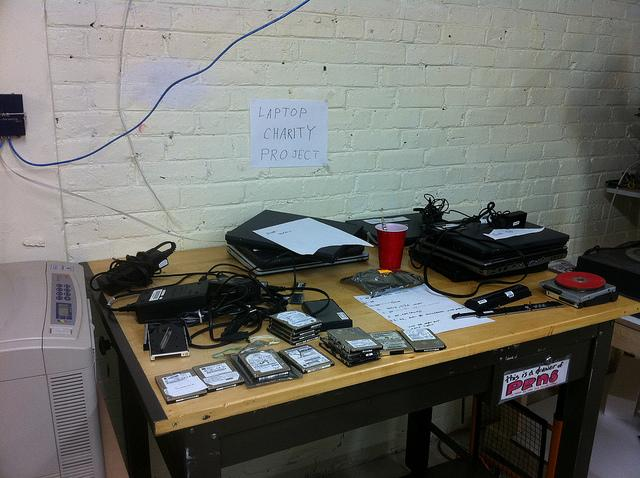What is likely the most valuable object shown?

Choices:
A) power bars
B) photocopier
C) cds
D) hard drives photocopier 